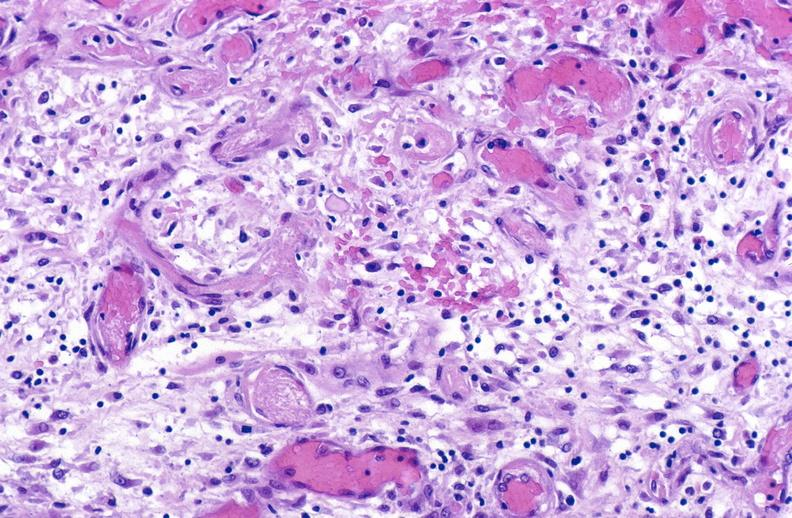what is present?
Answer the question using a single word or phrase. Soft tissue 